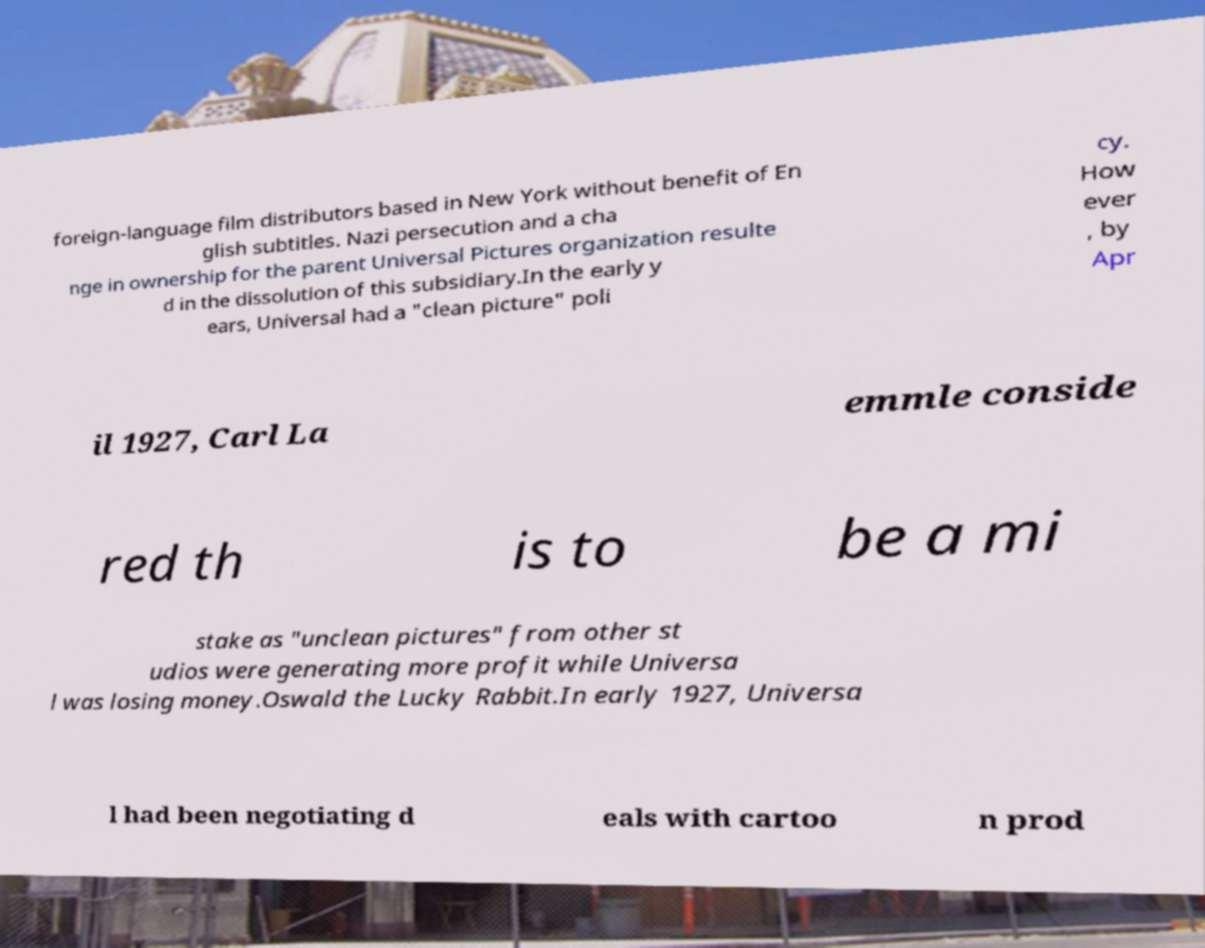Can you accurately transcribe the text from the provided image for me? foreign-language film distributors based in New York without benefit of En glish subtitles. Nazi persecution and a cha nge in ownership for the parent Universal Pictures organization resulte d in the dissolution of this subsidiary.In the early y ears, Universal had a "clean picture" poli cy. How ever , by Apr il 1927, Carl La emmle conside red th is to be a mi stake as "unclean pictures" from other st udios were generating more profit while Universa l was losing money.Oswald the Lucky Rabbit.In early 1927, Universa l had been negotiating d eals with cartoo n prod 